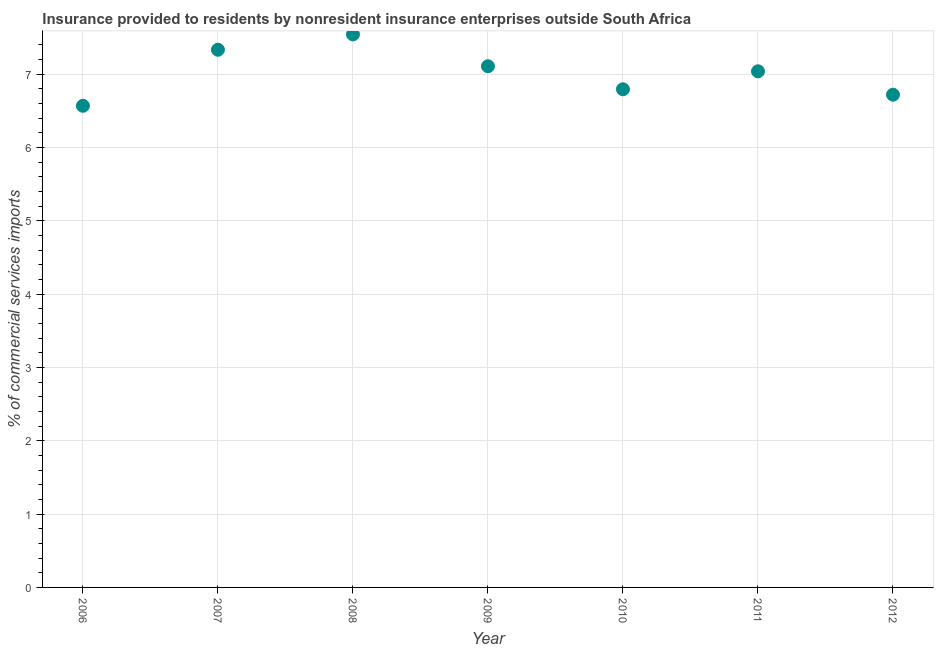What is the insurance provided by non-residents in 2007?
Your answer should be compact. 7.33. Across all years, what is the maximum insurance provided by non-residents?
Your answer should be very brief. 7.54. Across all years, what is the minimum insurance provided by non-residents?
Ensure brevity in your answer.  6.57. In which year was the insurance provided by non-residents minimum?
Keep it short and to the point. 2006. What is the sum of the insurance provided by non-residents?
Make the answer very short. 49.1. What is the difference between the insurance provided by non-residents in 2006 and 2012?
Make the answer very short. -0.15. What is the average insurance provided by non-residents per year?
Keep it short and to the point. 7.01. What is the median insurance provided by non-residents?
Make the answer very short. 7.04. What is the ratio of the insurance provided by non-residents in 2006 to that in 2008?
Give a very brief answer. 0.87. Is the insurance provided by non-residents in 2006 less than that in 2008?
Your answer should be compact. Yes. Is the difference between the insurance provided by non-residents in 2007 and 2011 greater than the difference between any two years?
Provide a succinct answer. No. What is the difference between the highest and the second highest insurance provided by non-residents?
Your answer should be compact. 0.21. Is the sum of the insurance provided by non-residents in 2009 and 2010 greater than the maximum insurance provided by non-residents across all years?
Your answer should be very brief. Yes. What is the difference between the highest and the lowest insurance provided by non-residents?
Provide a short and direct response. 0.97. Does the insurance provided by non-residents monotonically increase over the years?
Your answer should be compact. No. How many dotlines are there?
Make the answer very short. 1. What is the difference between two consecutive major ticks on the Y-axis?
Give a very brief answer. 1. Does the graph contain any zero values?
Ensure brevity in your answer.  No. Does the graph contain grids?
Keep it short and to the point. Yes. What is the title of the graph?
Your response must be concise. Insurance provided to residents by nonresident insurance enterprises outside South Africa. What is the label or title of the Y-axis?
Your answer should be compact. % of commercial services imports. What is the % of commercial services imports in 2006?
Keep it short and to the point. 6.57. What is the % of commercial services imports in 2007?
Your response must be concise. 7.33. What is the % of commercial services imports in 2008?
Give a very brief answer. 7.54. What is the % of commercial services imports in 2009?
Offer a very short reply. 7.11. What is the % of commercial services imports in 2010?
Offer a very short reply. 6.79. What is the % of commercial services imports in 2011?
Provide a short and direct response. 7.04. What is the % of commercial services imports in 2012?
Your response must be concise. 6.72. What is the difference between the % of commercial services imports in 2006 and 2007?
Give a very brief answer. -0.76. What is the difference between the % of commercial services imports in 2006 and 2008?
Offer a very short reply. -0.97. What is the difference between the % of commercial services imports in 2006 and 2009?
Give a very brief answer. -0.54. What is the difference between the % of commercial services imports in 2006 and 2010?
Give a very brief answer. -0.23. What is the difference between the % of commercial services imports in 2006 and 2011?
Provide a succinct answer. -0.47. What is the difference between the % of commercial services imports in 2006 and 2012?
Your answer should be very brief. -0.15. What is the difference between the % of commercial services imports in 2007 and 2008?
Make the answer very short. -0.21. What is the difference between the % of commercial services imports in 2007 and 2009?
Provide a short and direct response. 0.23. What is the difference between the % of commercial services imports in 2007 and 2010?
Your response must be concise. 0.54. What is the difference between the % of commercial services imports in 2007 and 2011?
Provide a succinct answer. 0.29. What is the difference between the % of commercial services imports in 2007 and 2012?
Provide a succinct answer. 0.61. What is the difference between the % of commercial services imports in 2008 and 2009?
Provide a succinct answer. 0.43. What is the difference between the % of commercial services imports in 2008 and 2010?
Offer a terse response. 0.75. What is the difference between the % of commercial services imports in 2008 and 2011?
Ensure brevity in your answer.  0.5. What is the difference between the % of commercial services imports in 2008 and 2012?
Give a very brief answer. 0.82. What is the difference between the % of commercial services imports in 2009 and 2010?
Your answer should be compact. 0.31. What is the difference between the % of commercial services imports in 2009 and 2011?
Offer a very short reply. 0.07. What is the difference between the % of commercial services imports in 2009 and 2012?
Ensure brevity in your answer.  0.39. What is the difference between the % of commercial services imports in 2010 and 2011?
Offer a very short reply. -0.24. What is the difference between the % of commercial services imports in 2010 and 2012?
Provide a succinct answer. 0.07. What is the difference between the % of commercial services imports in 2011 and 2012?
Keep it short and to the point. 0.32. What is the ratio of the % of commercial services imports in 2006 to that in 2007?
Your answer should be compact. 0.9. What is the ratio of the % of commercial services imports in 2006 to that in 2008?
Your answer should be very brief. 0.87. What is the ratio of the % of commercial services imports in 2006 to that in 2009?
Provide a succinct answer. 0.92. What is the ratio of the % of commercial services imports in 2006 to that in 2011?
Your answer should be compact. 0.93. What is the ratio of the % of commercial services imports in 2006 to that in 2012?
Your answer should be very brief. 0.98. What is the ratio of the % of commercial services imports in 2007 to that in 2009?
Offer a very short reply. 1.03. What is the ratio of the % of commercial services imports in 2007 to that in 2010?
Provide a succinct answer. 1.08. What is the ratio of the % of commercial services imports in 2007 to that in 2011?
Give a very brief answer. 1.04. What is the ratio of the % of commercial services imports in 2007 to that in 2012?
Your answer should be very brief. 1.09. What is the ratio of the % of commercial services imports in 2008 to that in 2009?
Your answer should be compact. 1.06. What is the ratio of the % of commercial services imports in 2008 to that in 2010?
Ensure brevity in your answer.  1.11. What is the ratio of the % of commercial services imports in 2008 to that in 2011?
Ensure brevity in your answer.  1.07. What is the ratio of the % of commercial services imports in 2008 to that in 2012?
Keep it short and to the point. 1.12. What is the ratio of the % of commercial services imports in 2009 to that in 2010?
Offer a very short reply. 1.05. What is the ratio of the % of commercial services imports in 2009 to that in 2012?
Provide a succinct answer. 1.06. What is the ratio of the % of commercial services imports in 2010 to that in 2012?
Make the answer very short. 1.01. What is the ratio of the % of commercial services imports in 2011 to that in 2012?
Offer a terse response. 1.05. 